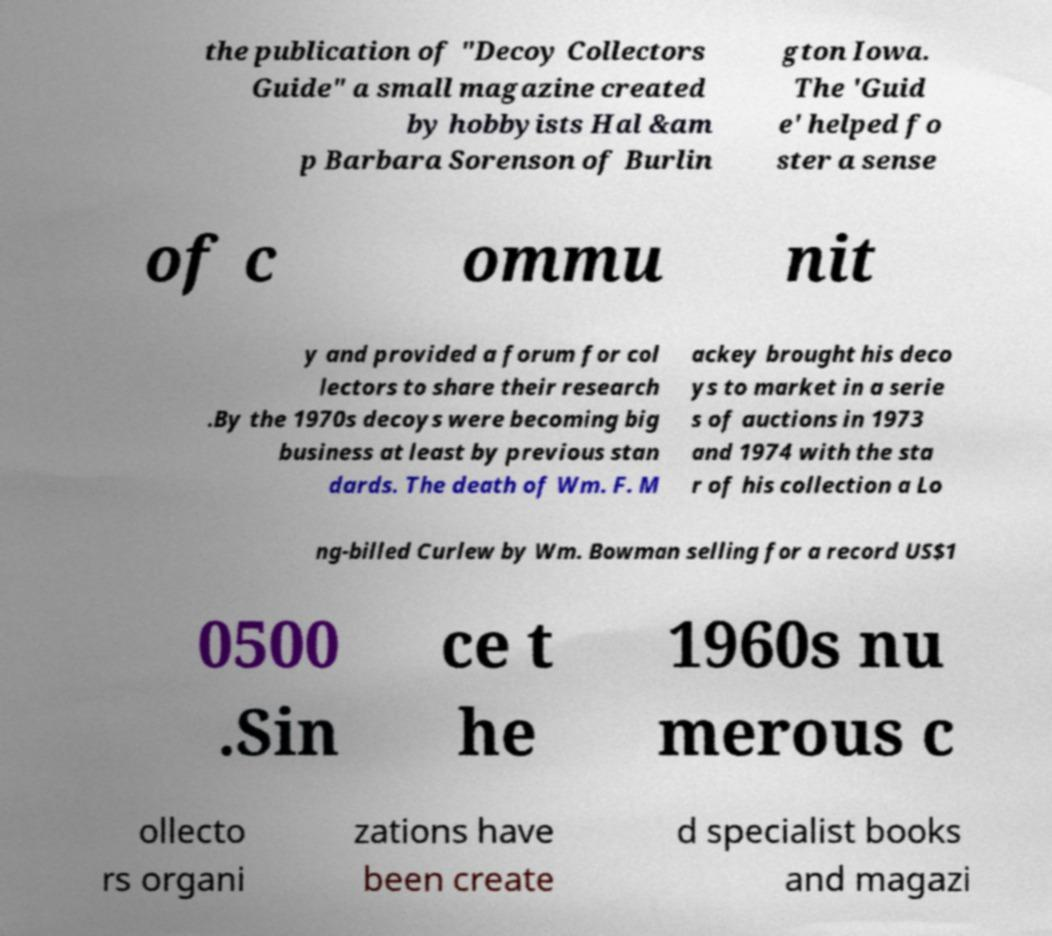Please read and relay the text visible in this image. What does it say? the publication of "Decoy Collectors Guide" a small magazine created by hobbyists Hal &am p Barbara Sorenson of Burlin gton Iowa. The 'Guid e' helped fo ster a sense of c ommu nit y and provided a forum for col lectors to share their research .By the 1970s decoys were becoming big business at least by previous stan dards. The death of Wm. F. M ackey brought his deco ys to market in a serie s of auctions in 1973 and 1974 with the sta r of his collection a Lo ng-billed Curlew by Wm. Bowman selling for a record US$1 0500 .Sin ce t he 1960s nu merous c ollecto rs organi zations have been create d specialist books and magazi 